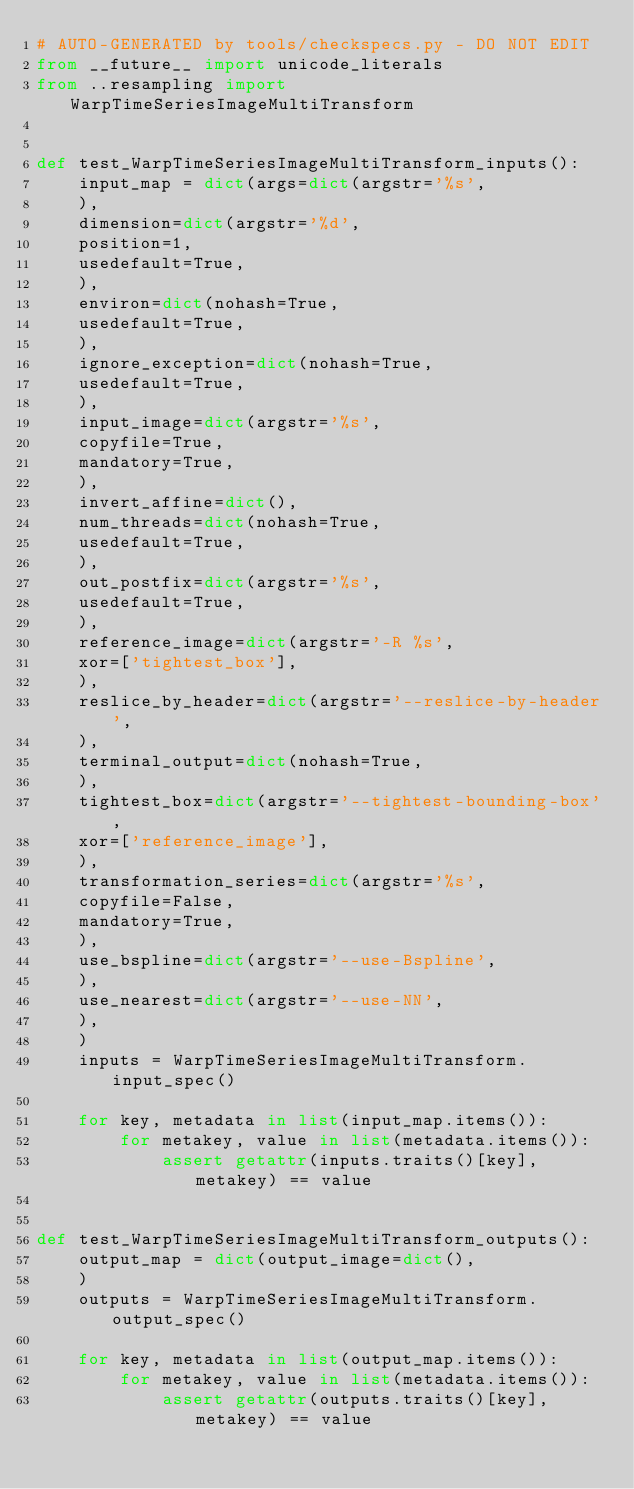Convert code to text. <code><loc_0><loc_0><loc_500><loc_500><_Python_># AUTO-GENERATED by tools/checkspecs.py - DO NOT EDIT
from __future__ import unicode_literals
from ..resampling import WarpTimeSeriesImageMultiTransform


def test_WarpTimeSeriesImageMultiTransform_inputs():
    input_map = dict(args=dict(argstr='%s',
    ),
    dimension=dict(argstr='%d',
    position=1,
    usedefault=True,
    ),
    environ=dict(nohash=True,
    usedefault=True,
    ),
    ignore_exception=dict(nohash=True,
    usedefault=True,
    ),
    input_image=dict(argstr='%s',
    copyfile=True,
    mandatory=True,
    ),
    invert_affine=dict(),
    num_threads=dict(nohash=True,
    usedefault=True,
    ),
    out_postfix=dict(argstr='%s',
    usedefault=True,
    ),
    reference_image=dict(argstr='-R %s',
    xor=['tightest_box'],
    ),
    reslice_by_header=dict(argstr='--reslice-by-header',
    ),
    terminal_output=dict(nohash=True,
    ),
    tightest_box=dict(argstr='--tightest-bounding-box',
    xor=['reference_image'],
    ),
    transformation_series=dict(argstr='%s',
    copyfile=False,
    mandatory=True,
    ),
    use_bspline=dict(argstr='--use-Bspline',
    ),
    use_nearest=dict(argstr='--use-NN',
    ),
    )
    inputs = WarpTimeSeriesImageMultiTransform.input_spec()

    for key, metadata in list(input_map.items()):
        for metakey, value in list(metadata.items()):
            assert getattr(inputs.traits()[key], metakey) == value


def test_WarpTimeSeriesImageMultiTransform_outputs():
    output_map = dict(output_image=dict(),
    )
    outputs = WarpTimeSeriesImageMultiTransform.output_spec()

    for key, metadata in list(output_map.items()):
        for metakey, value in list(metadata.items()):
            assert getattr(outputs.traits()[key], metakey) == value
</code> 